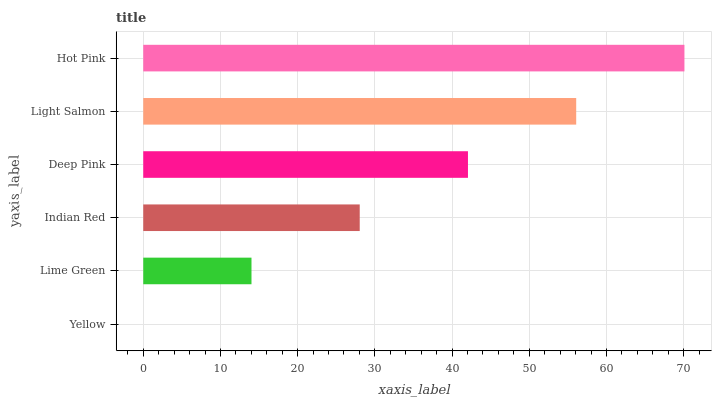Is Yellow the minimum?
Answer yes or no. Yes. Is Hot Pink the maximum?
Answer yes or no. Yes. Is Lime Green the minimum?
Answer yes or no. No. Is Lime Green the maximum?
Answer yes or no. No. Is Lime Green greater than Yellow?
Answer yes or no. Yes. Is Yellow less than Lime Green?
Answer yes or no. Yes. Is Yellow greater than Lime Green?
Answer yes or no. No. Is Lime Green less than Yellow?
Answer yes or no. No. Is Deep Pink the high median?
Answer yes or no. Yes. Is Indian Red the low median?
Answer yes or no. Yes. Is Lime Green the high median?
Answer yes or no. No. Is Hot Pink the low median?
Answer yes or no. No. 